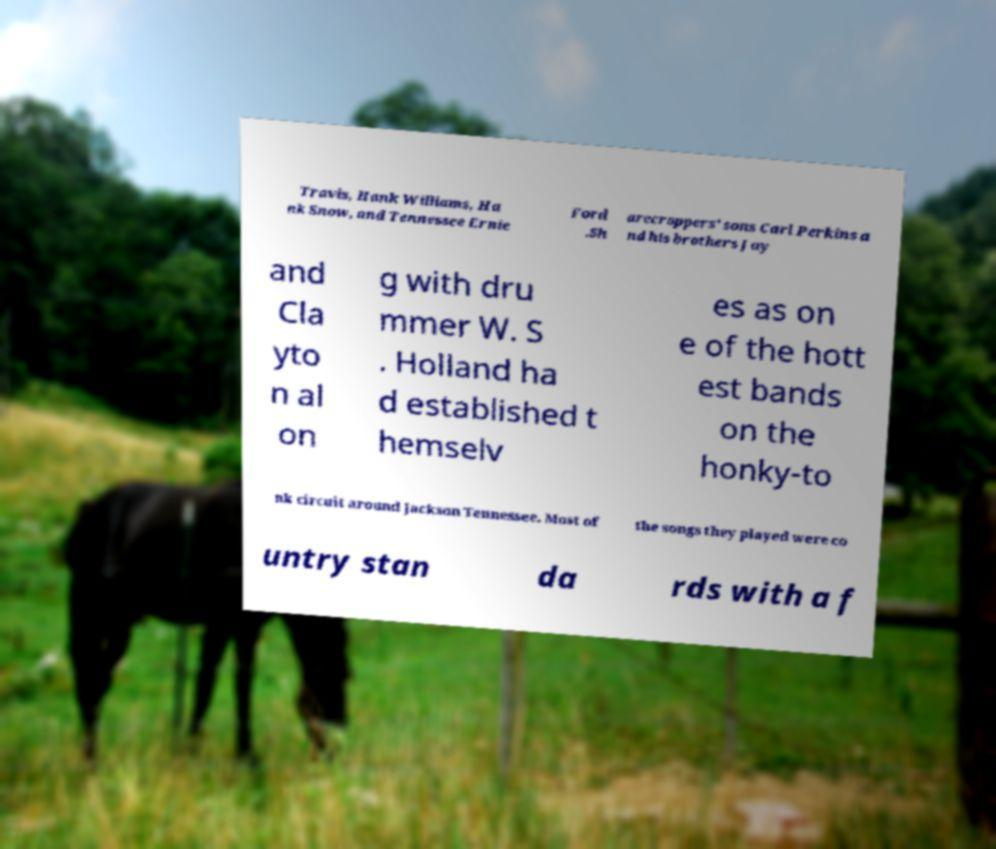I need the written content from this picture converted into text. Can you do that? Travis, Hank Williams, Ha nk Snow, and Tennessee Ernie Ford .Sh arecroppers' sons Carl Perkins a nd his brothers Jay and Cla yto n al on g with dru mmer W. S . Holland ha d established t hemselv es as on e of the hott est bands on the honky-to nk circuit around Jackson Tennessee. Most of the songs they played were co untry stan da rds with a f 